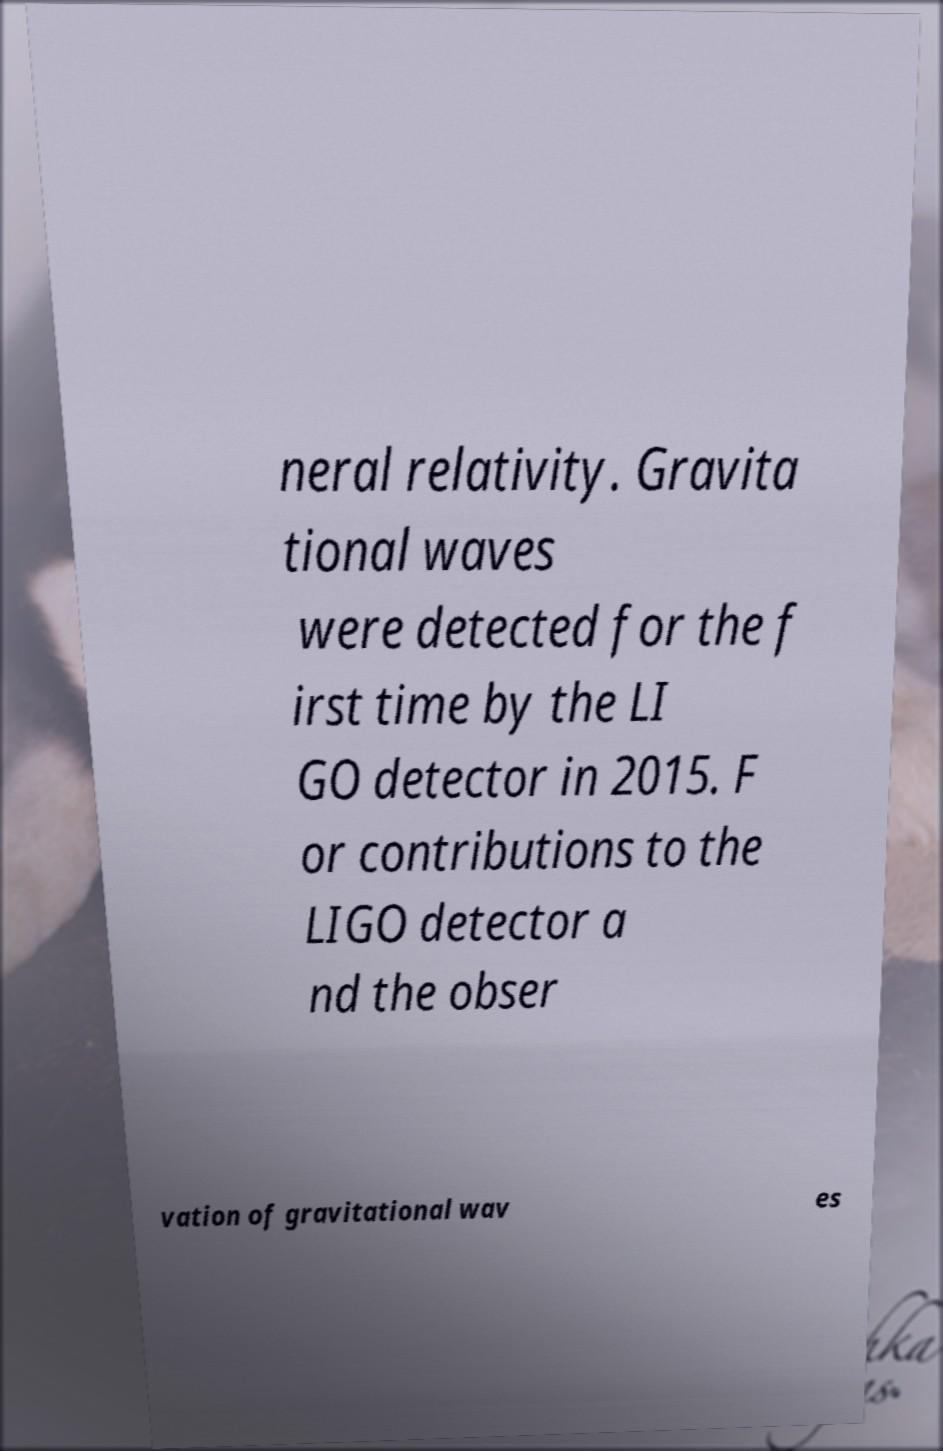For documentation purposes, I need the text within this image transcribed. Could you provide that? neral relativity. Gravita tional waves were detected for the f irst time by the LI GO detector in 2015. F or contributions to the LIGO detector a nd the obser vation of gravitational wav es 